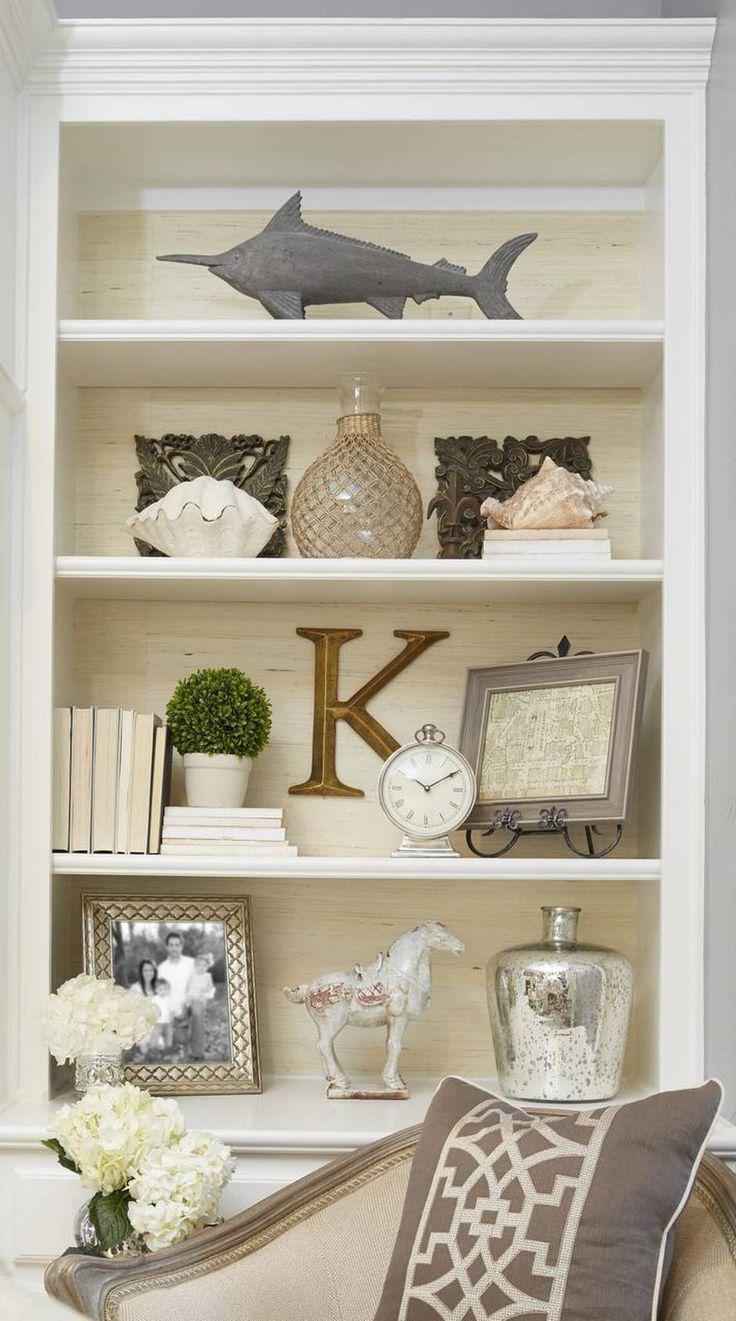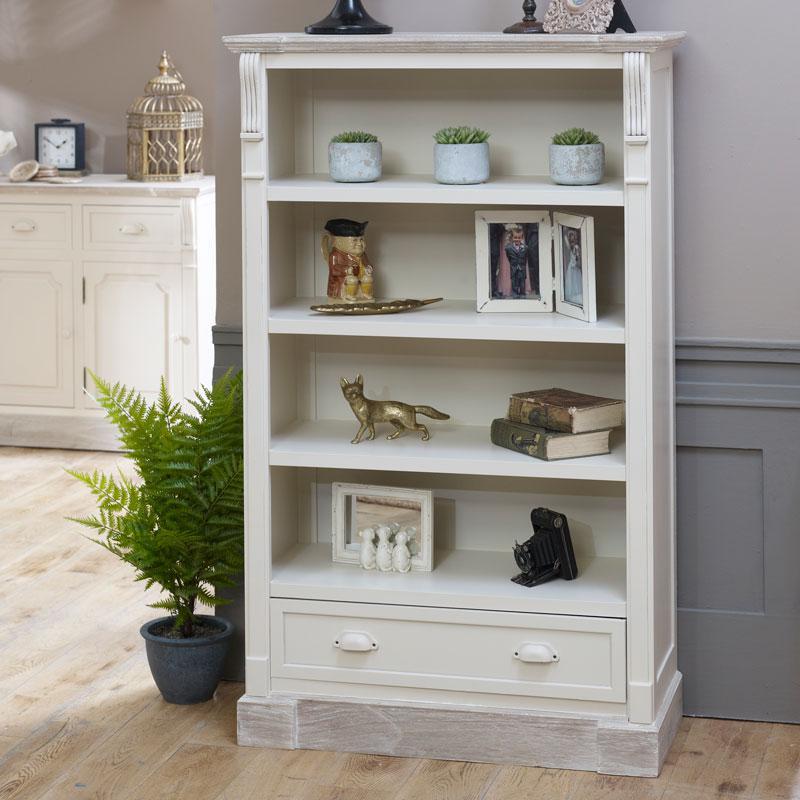The first image is the image on the left, the second image is the image on the right. Analyze the images presented: Is the assertion "A room image features seating furniture on the right and a bookcase with at least 8 shelves." valid? Answer yes or no. No. The first image is the image on the left, the second image is the image on the right. Given the left and right images, does the statement "In one image, a free-standing white shelf is in front of a wall." hold true? Answer yes or no. Yes. 